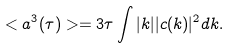<formula> <loc_0><loc_0><loc_500><loc_500>< a ^ { 3 } ( \tau ) > = 3 \tau \int | k | | c ( k ) | ^ { 2 } d k .</formula> 